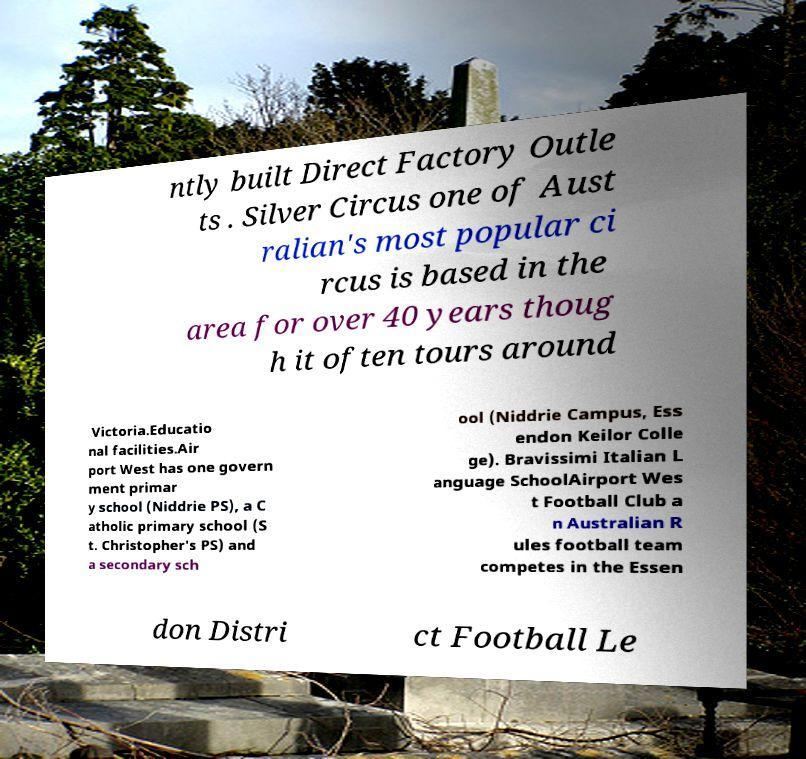I need the written content from this picture converted into text. Can you do that? ntly built Direct Factory Outle ts . Silver Circus one of Aust ralian's most popular ci rcus is based in the area for over 40 years thoug h it often tours around Victoria.Educatio nal facilities.Air port West has one govern ment primar y school (Niddrie PS), a C atholic primary school (S t. Christopher's PS) and a secondary sch ool (Niddrie Campus, Ess endon Keilor Colle ge). Bravissimi Italian L anguage SchoolAirport Wes t Football Club a n Australian R ules football team competes in the Essen don Distri ct Football Le 